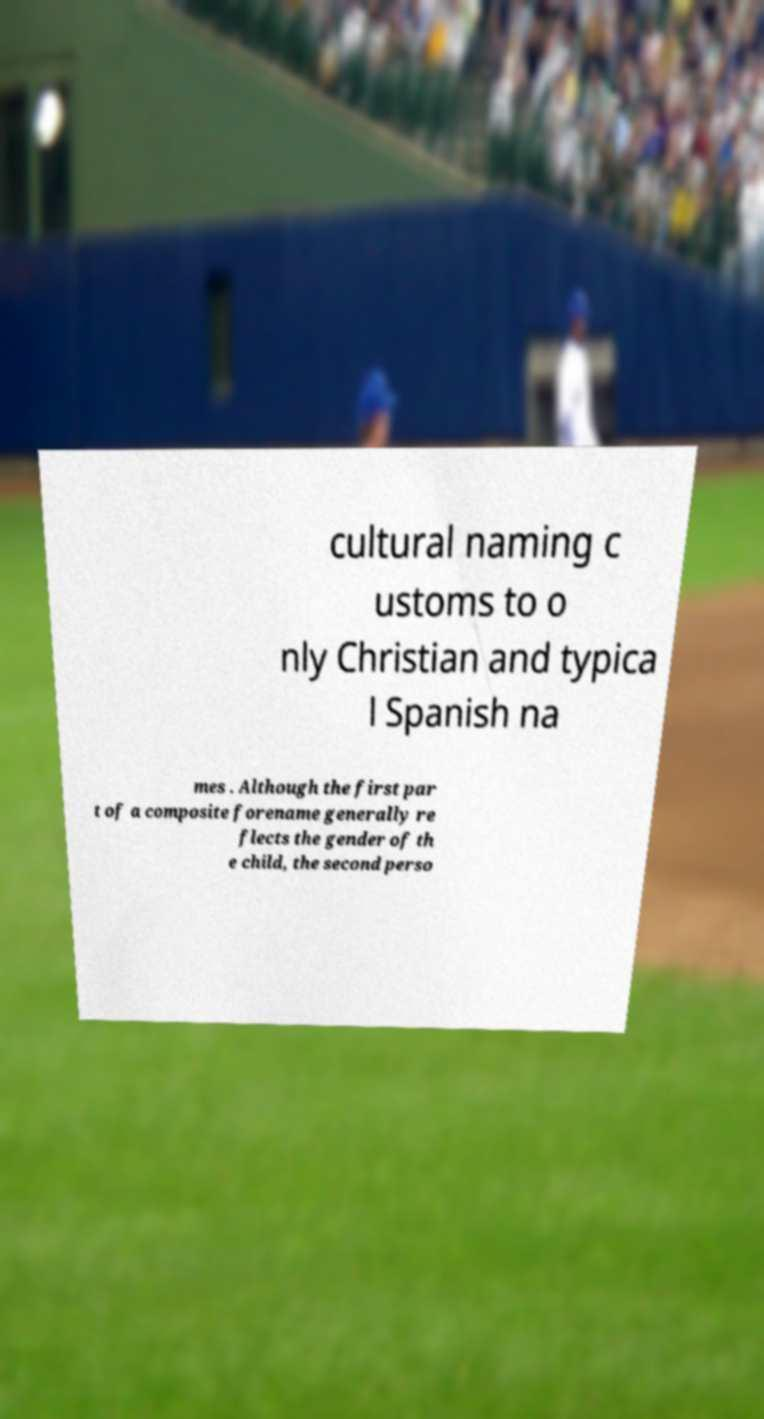Please read and relay the text visible in this image. What does it say? cultural naming c ustoms to o nly Christian and typica l Spanish na mes . Although the first par t of a composite forename generally re flects the gender of th e child, the second perso 